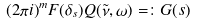Convert formula to latex. <formula><loc_0><loc_0><loc_500><loc_500>( 2 \pi i ) ^ { m } F ( \delta _ { s } ) Q ( \tilde { \nu } , \omega ) = \colon G ( s ) \\</formula> 